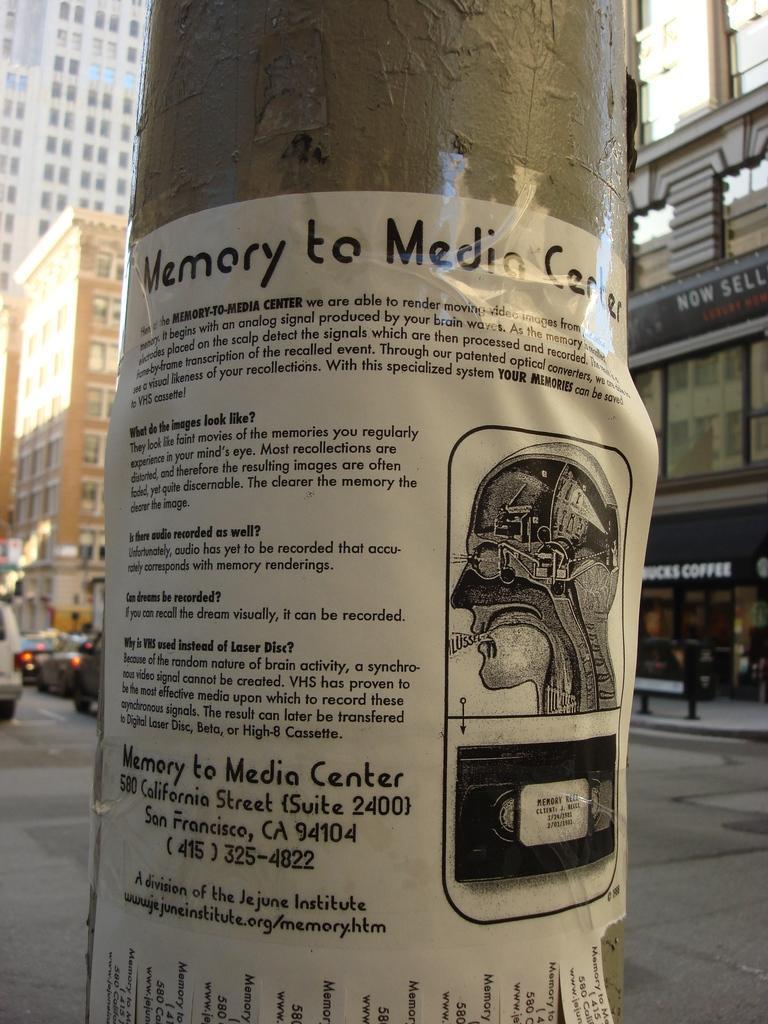Could you give a brief overview of what you see in this image? As we can see in the image there is a poster in the front. In the background there are buildings, bench and vehicles. 